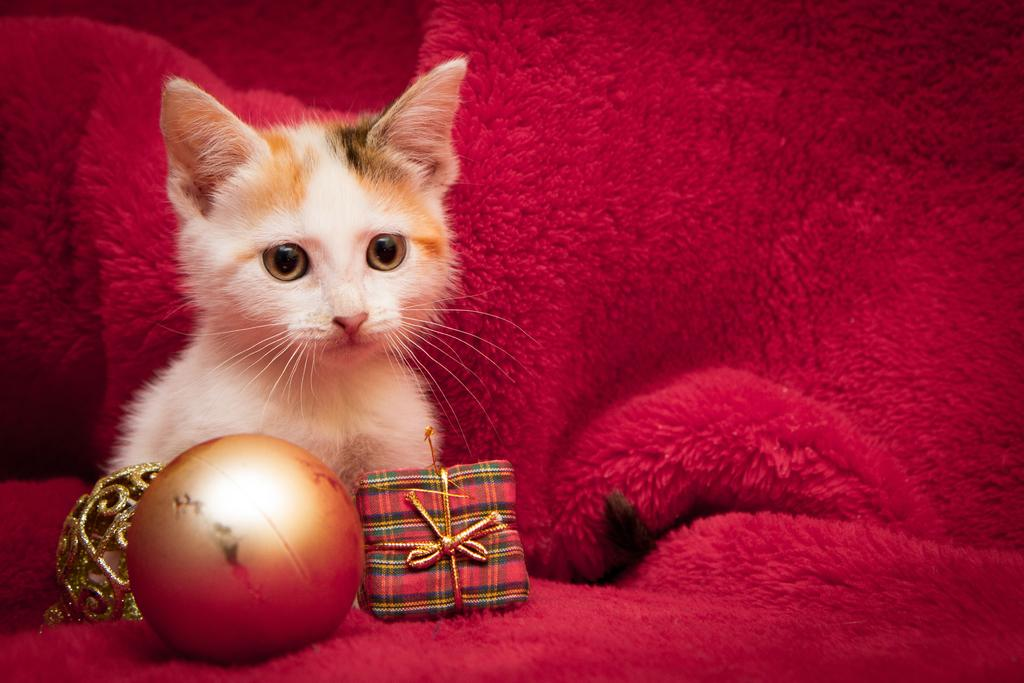What type of animal is in the image? There is a white cat in the image. What is the cat holding in its paws? The cat is holding a ball. What can be seen behind the cat? The cat is in front of a red sofa. Where is the maid located in the image? There is no maid present in the image. What type of basket is visible in the image? There is no basket present in the image. 